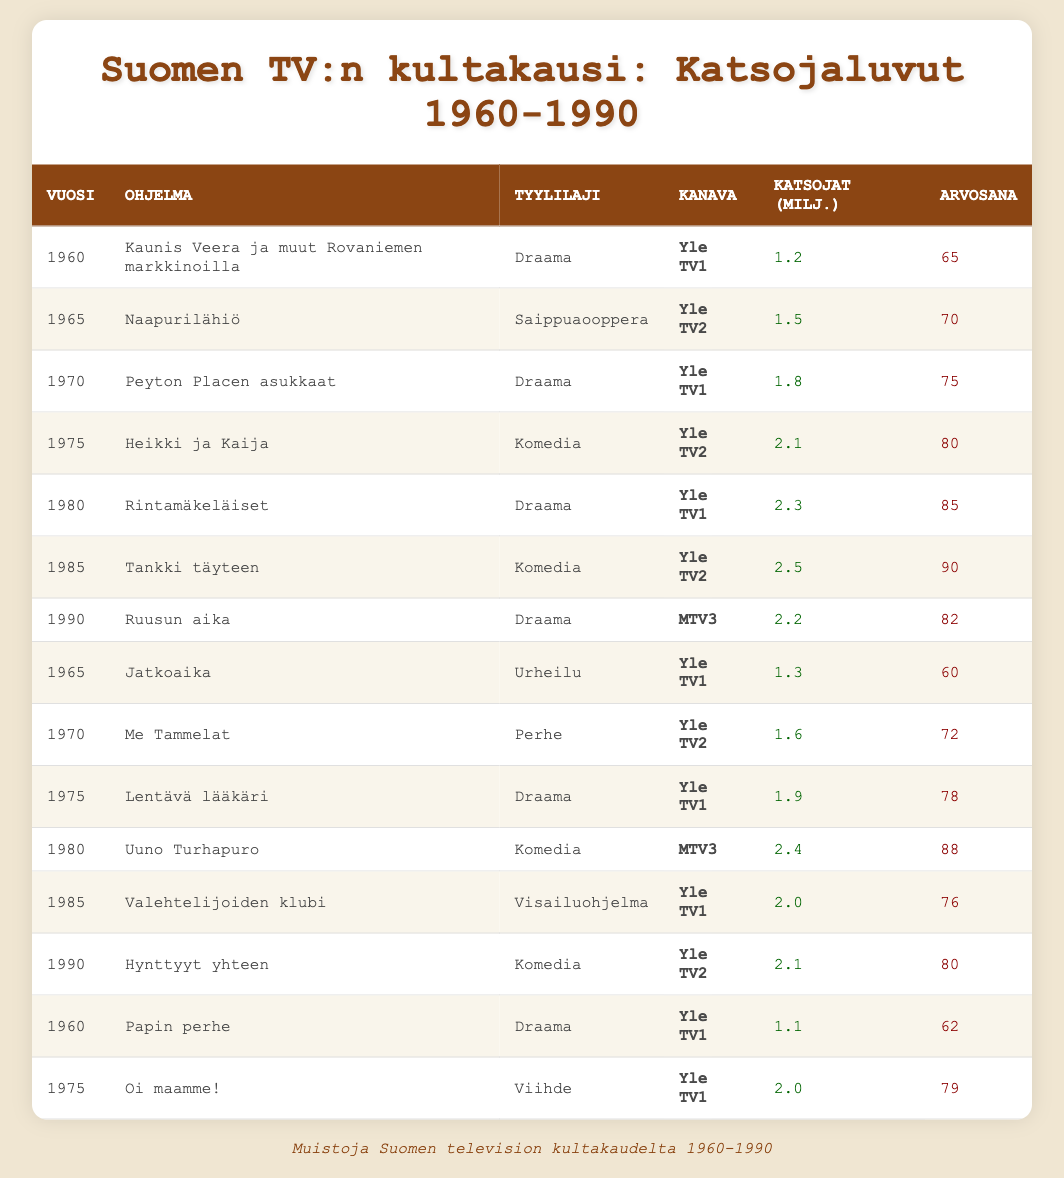What is the viewership rating for "Tankki täyteen"? The table lists "Tankki täyteen" under the year 1985, showing a rating of 90.
Answer: 90 In which year did "Uuno Turhapuro" achieve its viewers? According to the table, "Uuno Turhapuro" aired in 1980 with 2.4 million viewers.
Answer: 1980 Which show had the highest viewership among drama series? "Rintamäkeläiset" has 2.3 million viewers in 1980, which is higher than other drama series: "Kaunis Veera ja muut Rovaniemen markkinoilla" (1.2 million in 1960), "Peyton Placen asukkaat" (1.8 million in 1970), "Lentävä lääkäri" (1.9 million in 1975), and "Ruusun aika" (2.2 million in 1990).
Answer: Rintamäkeläiset What is the total viewership in millions for the shows aired in 1975? The viewership for 1975 shows includes "Heikki ja Kaija" (2.1), "Lentävä lääkäri" (1.9), and "Oi maamme!" (2.0). Adding these gives: 2.1 + 1.9 + 2.0 = 6.0 million viewers.
Answer: 6.0 million Did "Me Tammelat" have a higher viewership than "Jatkoaika"? "Me Tammelat" had 1.6 million viewers in 1970, while "Jatkoaika" had 1.3 million viewers in 1965. Therefore, Me Tammelat's viewership was indeed higher.
Answer: Yes Which genre had the most shows listed in the table? The genres can be counted: Drama appears five times (Kaunis Veera, Peyton Placen asukkaat, Rintamäkeläiset, Lentävä lääkäri, Ruusun aika). Comedy appears three times (Heikki ja Kaija, Tankki täyteen, Uuno Turhapuro). Soap Opera, Sports, Family, Varieties, and Game Show appear once each. Drama has the most entries.
Answer: Drama What was the average number of viewers for comedy shows from 1960 to 1990? The comedy shows listed are "Heikki ja Kaija" (2.1), "Tankki täyteen" (2.5), and "Uuno Turhapuro" (2.4). The average is calculated as (2.1 + 2.5 + 2.4) / 3 = 2.33 million viewers.
Answer: 2.33 million Which channel aired "Hynttyyt yhteen"? The table indicates that "Hynttyyt yhteen" aired on Yle TV2 in 1990.
Answer: Yle TV2 What is the highest viewers count for a show aired on Yle TV1? The highest viewers count on Yle TV1 is 2.4 million for "Uuno Turhapuro" in 1980.
Answer: 2.4 million 